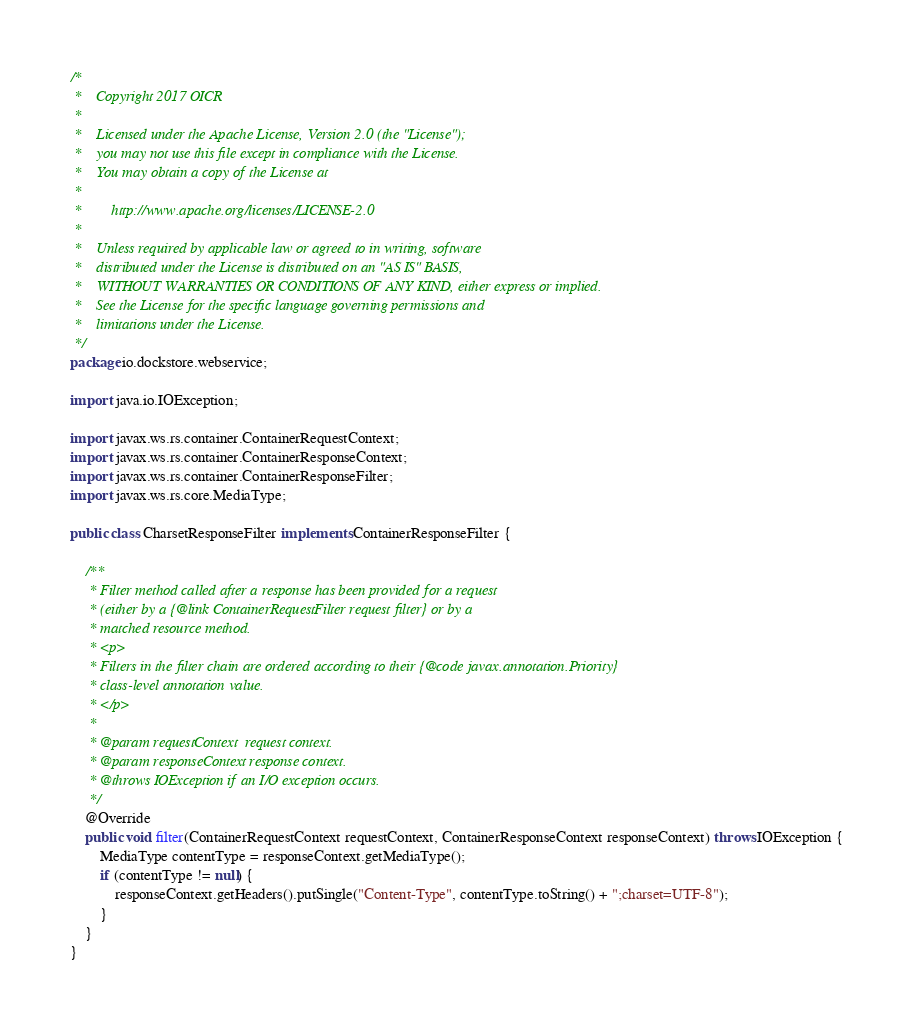Convert code to text. <code><loc_0><loc_0><loc_500><loc_500><_Java_>/*
 *    Copyright 2017 OICR
 *
 *    Licensed under the Apache License, Version 2.0 (the "License");
 *    you may not use this file except in compliance with the License.
 *    You may obtain a copy of the License at
 *
 *        http://www.apache.org/licenses/LICENSE-2.0
 *
 *    Unless required by applicable law or agreed to in writing, software
 *    distributed under the License is distributed on an "AS IS" BASIS,
 *    WITHOUT WARRANTIES OR CONDITIONS OF ANY KIND, either express or implied.
 *    See the License for the specific language governing permissions and
 *    limitations under the License.
 */
package io.dockstore.webservice;

import java.io.IOException;

import javax.ws.rs.container.ContainerRequestContext;
import javax.ws.rs.container.ContainerResponseContext;
import javax.ws.rs.container.ContainerResponseFilter;
import javax.ws.rs.core.MediaType;

public class CharsetResponseFilter implements ContainerResponseFilter {

    /**
     * Filter method called after a response has been provided for a request
     * (either by a {@link ContainerRequestFilter request filter} or by a
     * matched resource method.
     * <p>
     * Filters in the filter chain are ordered according to their {@code javax.annotation.Priority}
     * class-level annotation value.
     * </p>
     *
     * @param requestContext  request context.
     * @param responseContext response context.
     * @throws IOException if an I/O exception occurs.
     */
    @Override
    public void filter(ContainerRequestContext requestContext, ContainerResponseContext responseContext) throws IOException {
        MediaType contentType = responseContext.getMediaType();
        if (contentType != null) {
            responseContext.getHeaders().putSingle("Content-Type", contentType.toString() + ";charset=UTF-8");
        }
    }
}
</code> 